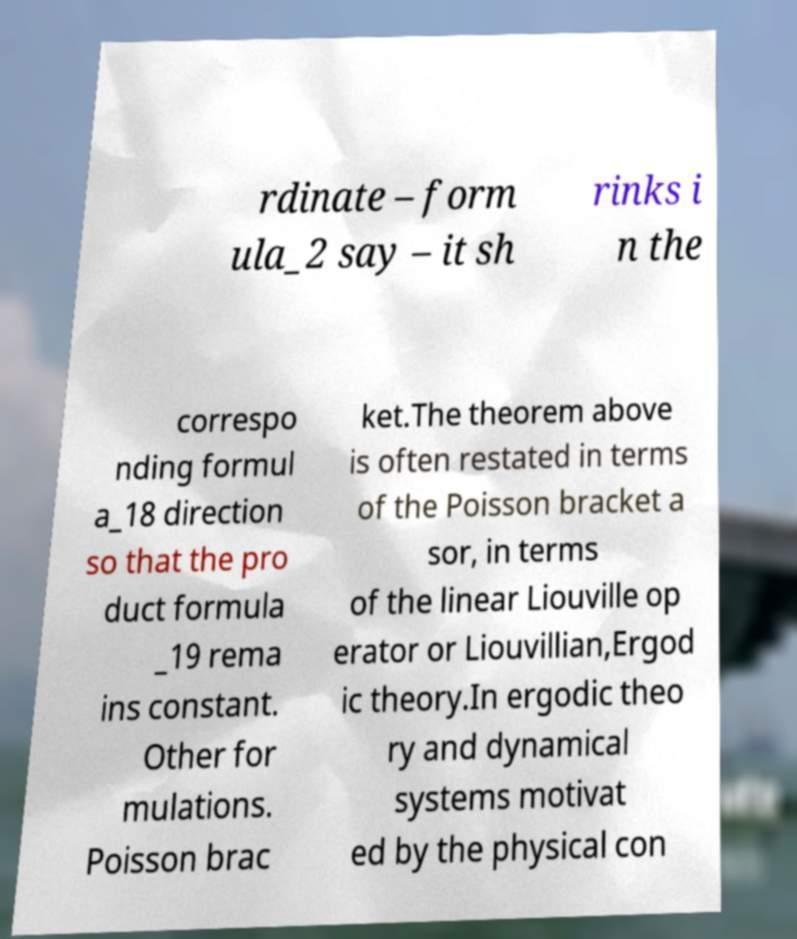Could you assist in decoding the text presented in this image and type it out clearly? rdinate – form ula_2 say – it sh rinks i n the correspo nding formul a_18 direction so that the pro duct formula _19 rema ins constant. Other for mulations. Poisson brac ket.The theorem above is often restated in terms of the Poisson bracket a sor, in terms of the linear Liouville op erator or Liouvillian,Ergod ic theory.In ergodic theo ry and dynamical systems motivat ed by the physical con 